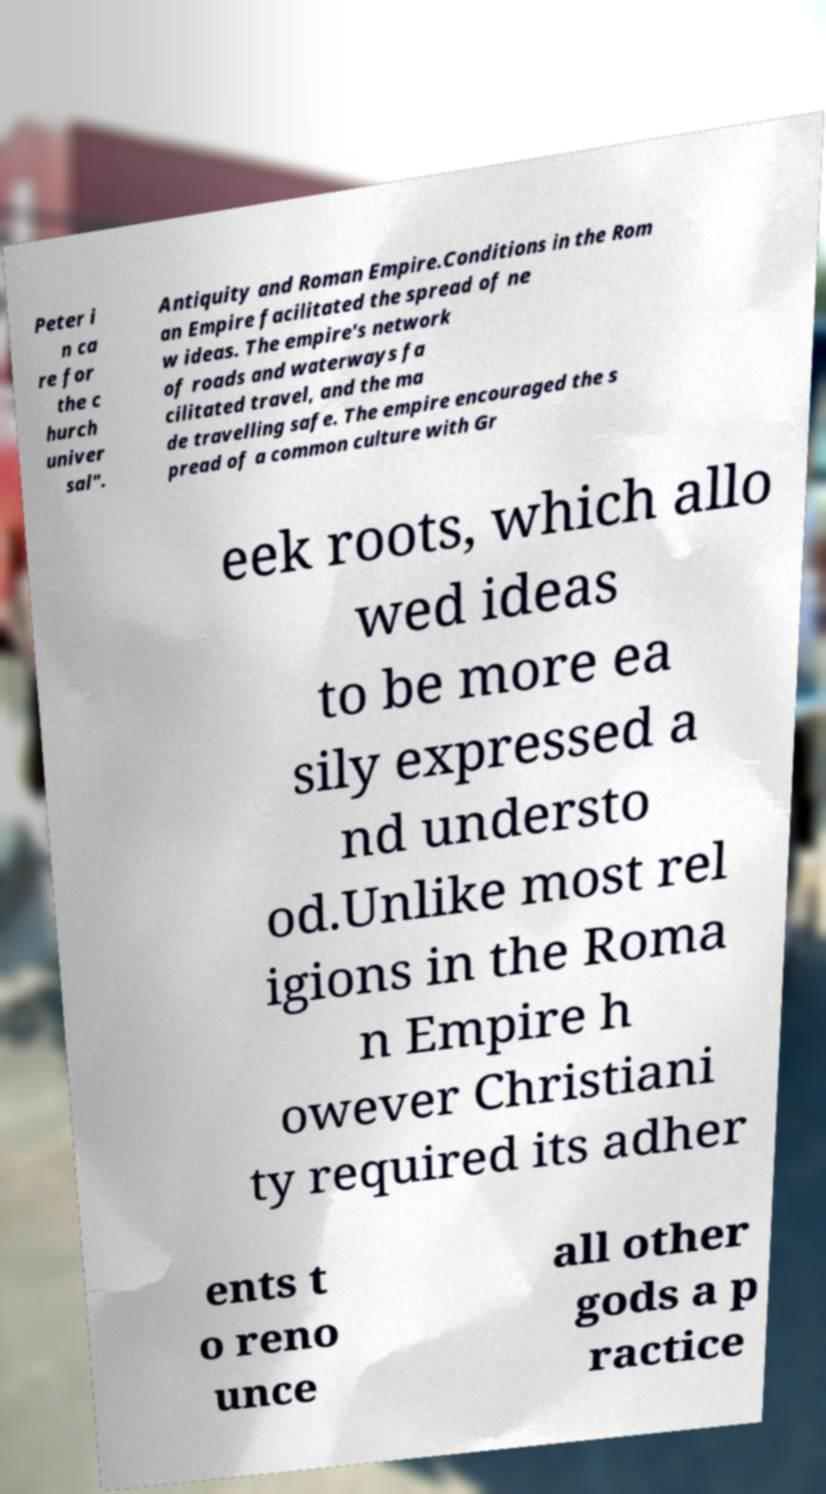Could you extract and type out the text from this image? Peter i n ca re for the c hurch univer sal". Antiquity and Roman Empire.Conditions in the Rom an Empire facilitated the spread of ne w ideas. The empire's network of roads and waterways fa cilitated travel, and the ma de travelling safe. The empire encouraged the s pread of a common culture with Gr eek roots, which allo wed ideas to be more ea sily expressed a nd understo od.Unlike most rel igions in the Roma n Empire h owever Christiani ty required its adher ents t o reno unce all other gods a p ractice 